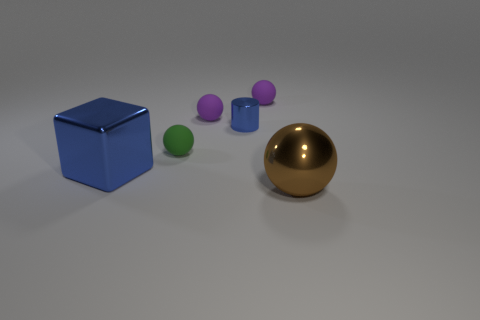There is a tiny cylinder that is the same color as the cube; what is its material?
Your answer should be compact. Metal. How many tiny things are the same color as the block?
Make the answer very short. 1. Does the blue thing in front of the tiny green object have the same shape as the green matte object?
Ensure brevity in your answer.  No. Are there fewer tiny green objects that are in front of the large brown shiny object than blue metal cylinders that are right of the tiny blue shiny cylinder?
Make the answer very short. No. There is a purple sphere that is right of the blue shiny cylinder; what material is it?
Your answer should be compact. Rubber. What is the size of the object that is the same color as the shiny cylinder?
Your response must be concise. Large. Are there any cubes that have the same size as the blue cylinder?
Give a very brief answer. No. Is the shape of the small blue object the same as the tiny thing right of the small shiny object?
Offer a terse response. No. Is the size of the blue shiny object on the left side of the small metallic object the same as the matte sphere that is right of the small blue thing?
Offer a very short reply. No. What number of other objects are there of the same shape as the green thing?
Offer a terse response. 3. 